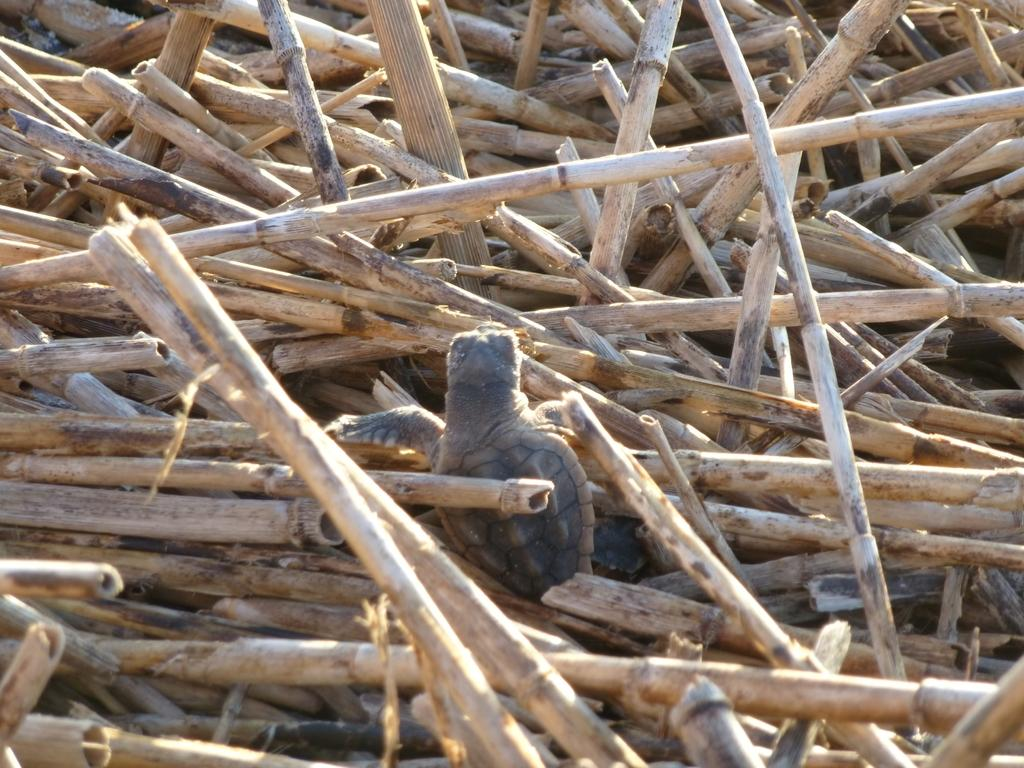What is the main subject of the image? The main subject of the image is a bunch of wooden sticks. Is there anything else present in the image besides the wooden sticks? Yes, a turtle is climbing on the wooden sticks. What is the income of the turtle in the image? There is no information about the turtle's income in the image, as it is not relevant to the image's content. 